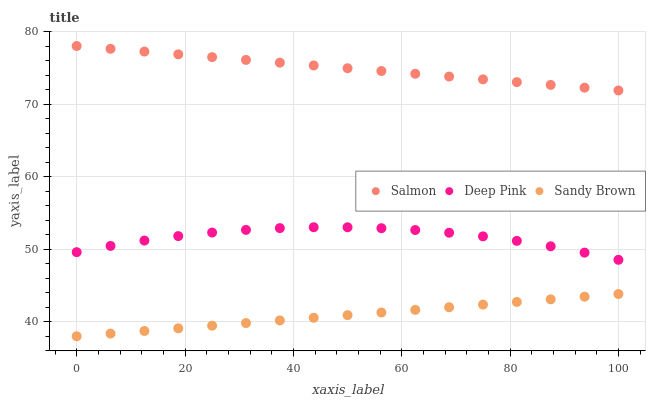Does Sandy Brown have the minimum area under the curve?
Answer yes or no. Yes. Does Salmon have the maximum area under the curve?
Answer yes or no. Yes. Does Deep Pink have the minimum area under the curve?
Answer yes or no. No. Does Deep Pink have the maximum area under the curve?
Answer yes or no. No. Is Sandy Brown the smoothest?
Answer yes or no. Yes. Is Deep Pink the roughest?
Answer yes or no. Yes. Is Salmon the smoothest?
Answer yes or no. No. Is Salmon the roughest?
Answer yes or no. No. Does Sandy Brown have the lowest value?
Answer yes or no. Yes. Does Deep Pink have the lowest value?
Answer yes or no. No. Does Salmon have the highest value?
Answer yes or no. Yes. Does Deep Pink have the highest value?
Answer yes or no. No. Is Sandy Brown less than Salmon?
Answer yes or no. Yes. Is Salmon greater than Deep Pink?
Answer yes or no. Yes. Does Sandy Brown intersect Salmon?
Answer yes or no. No. 